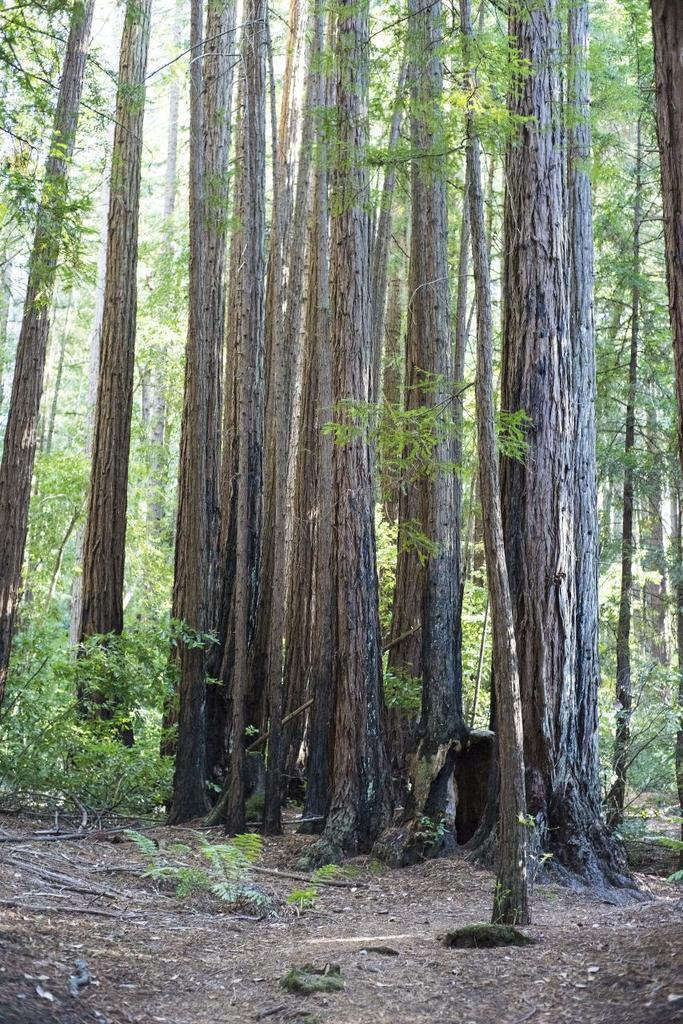What type of vegetation can be seen in the image? There are trees in the image. What nation is represented by the baby in the image? There is no baby present in the image, and therefore no nation can be represented. What hand gesture is being made by the trees in the image? Trees do not have the ability to make hand gestures, as they are plants and not living beings capable of such actions. 